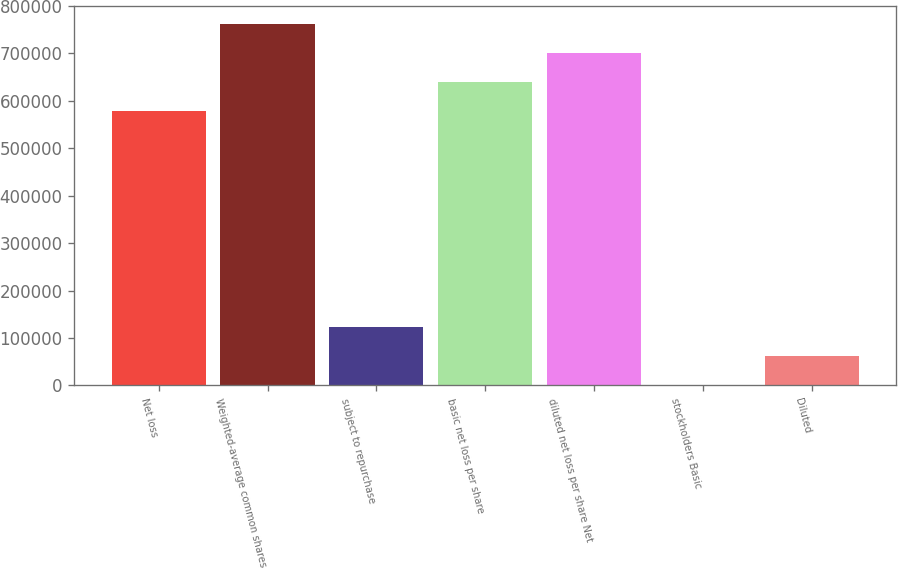Convert chart. <chart><loc_0><loc_0><loc_500><loc_500><bar_chart><fcel>Net loss<fcel>Weighted-average common shares<fcel>subject to repurchase<fcel>basic net loss per share<fcel>diluted net loss per share Net<fcel>stockholders Basic<fcel>Diluted<nl><fcel>577820<fcel>762003<fcel>122790<fcel>639214<fcel>700609<fcel>0.96<fcel>61395.3<nl></chart> 